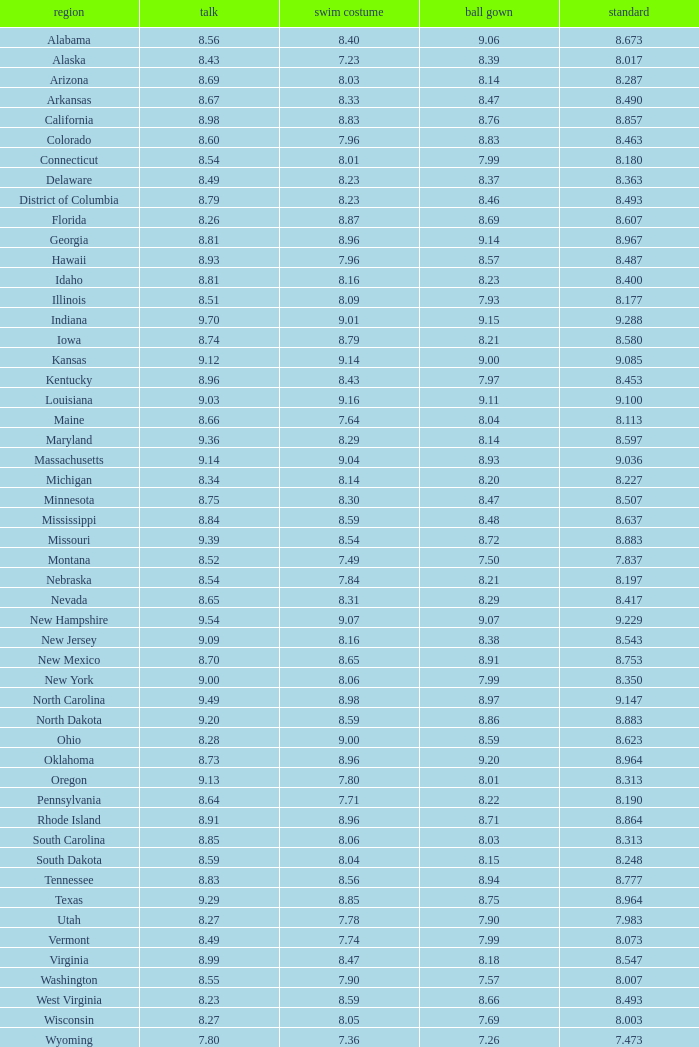Tell me the sum of interview for evening gown more than 8.37 and average of 8.363 None. 